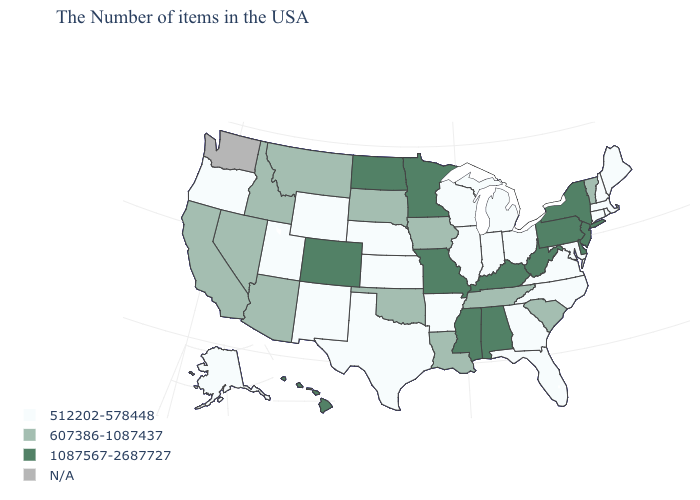Which states have the lowest value in the USA?
Keep it brief. Maine, Massachusetts, Rhode Island, New Hampshire, Connecticut, Maryland, Virginia, North Carolina, Ohio, Florida, Georgia, Michigan, Indiana, Wisconsin, Illinois, Arkansas, Kansas, Nebraska, Texas, Wyoming, New Mexico, Utah, Oregon, Alaska. How many symbols are there in the legend?
Concise answer only. 4. Name the states that have a value in the range N/A?
Short answer required. Washington. Which states have the highest value in the USA?
Keep it brief. New York, New Jersey, Delaware, Pennsylvania, West Virginia, Kentucky, Alabama, Mississippi, Missouri, Minnesota, North Dakota, Colorado, Hawaii. Does Colorado have the highest value in the West?
Keep it brief. Yes. What is the lowest value in states that border Idaho?
Keep it brief. 512202-578448. Does Hawaii have the highest value in the West?
Quick response, please. Yes. What is the value of West Virginia?
Answer briefly. 1087567-2687727. Among the states that border New York , does Connecticut have the lowest value?
Be succinct. Yes. Does Delaware have the highest value in the South?
Give a very brief answer. Yes. What is the value of Delaware?
Short answer required. 1087567-2687727. Among the states that border Arizona , does New Mexico have the highest value?
Concise answer only. No. Among the states that border Pennsylvania , does Ohio have the lowest value?
Short answer required. Yes. What is the value of Kansas?
Write a very short answer. 512202-578448. Does Arizona have the lowest value in the West?
Give a very brief answer. No. 